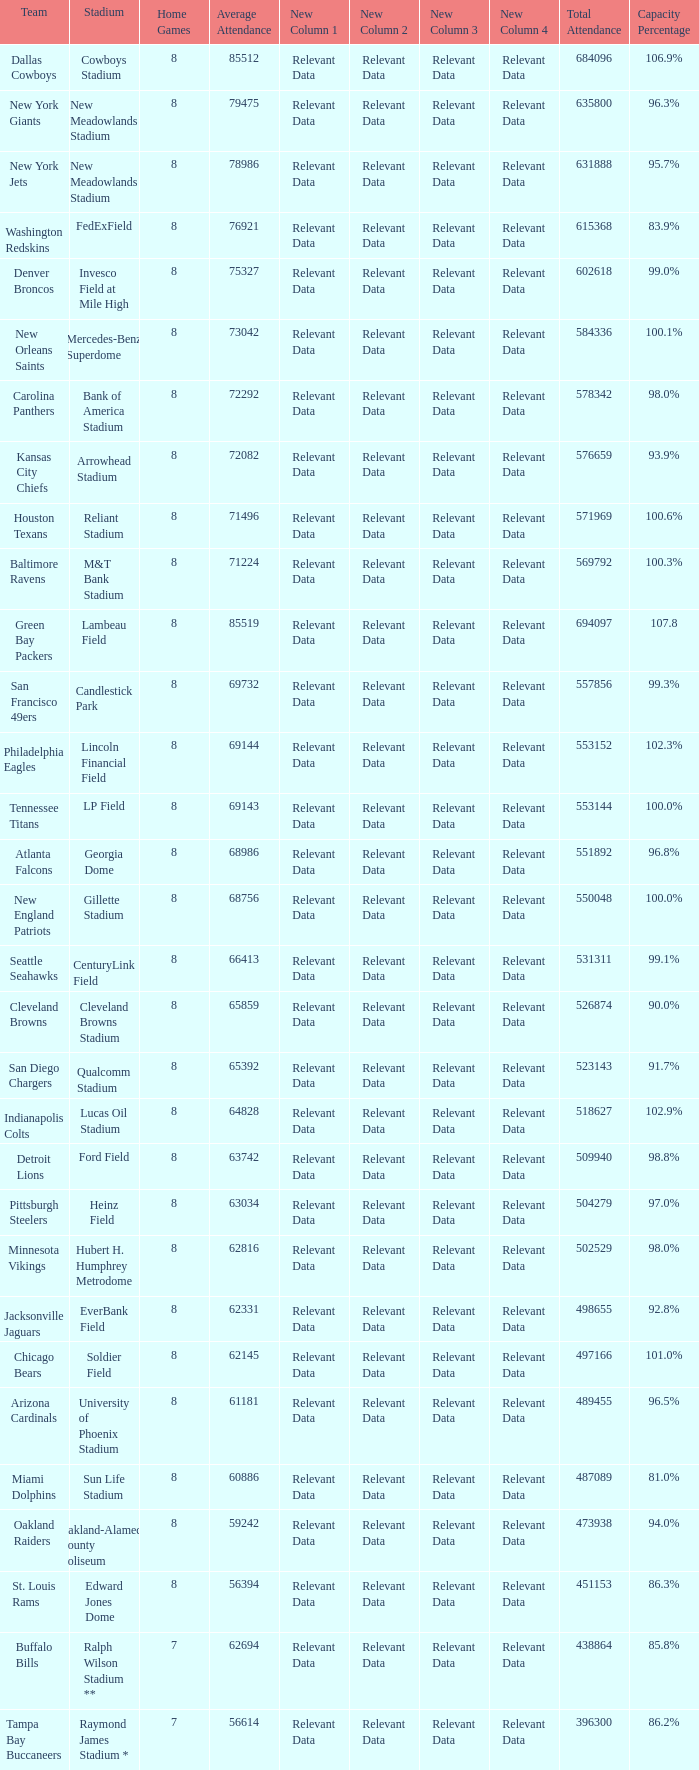How many home games are listed when the average attendance is 79475? 1.0. 